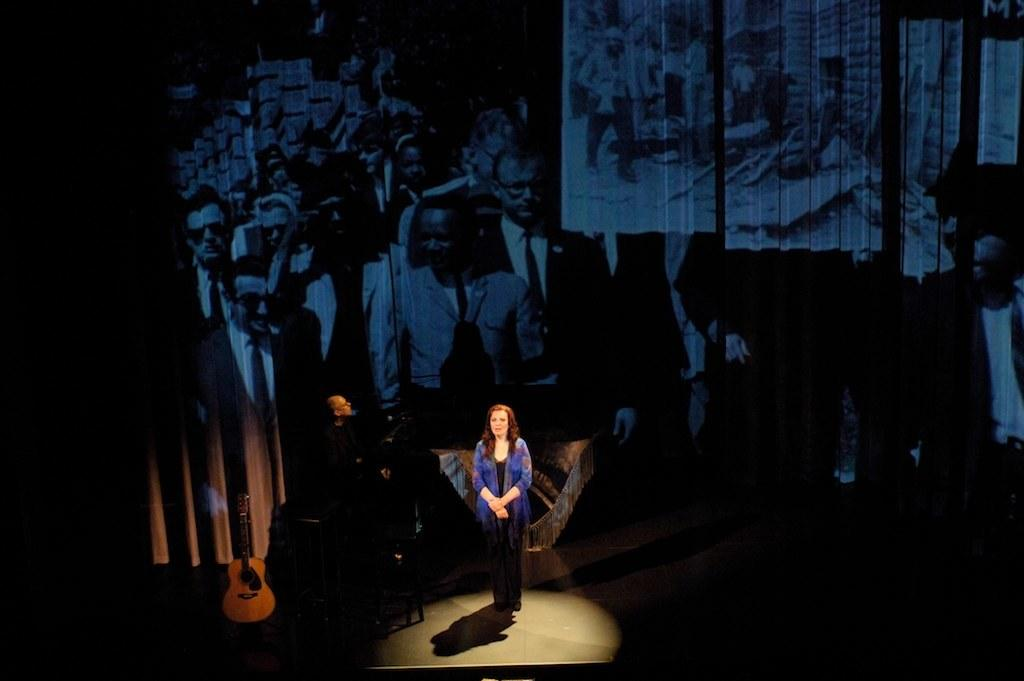How many people are present in the image? There are two people, a woman and a man, present in the image. What are the two people doing in the image? The image shows a woman and a man standing. What can be seen in the background of the image? There is a board with multiple people's images in the background. What type of wall can be seen in the image? There is no wall present in the image; it features a woman and a man standing with a board with multiple people's images in the background. What is the woman cooking in the image? There is no indication in the image that the woman is cooking, as she is simply standing. 